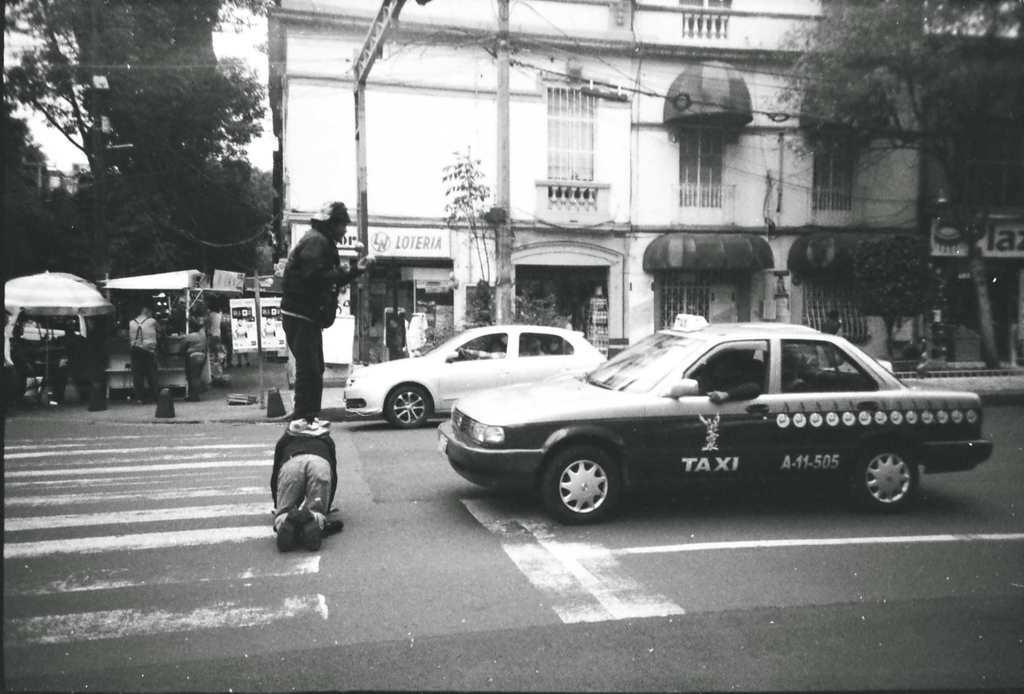<image>
Offer a succinct explanation of the picture presented. Two men stand in front of a taxi to impede it. 